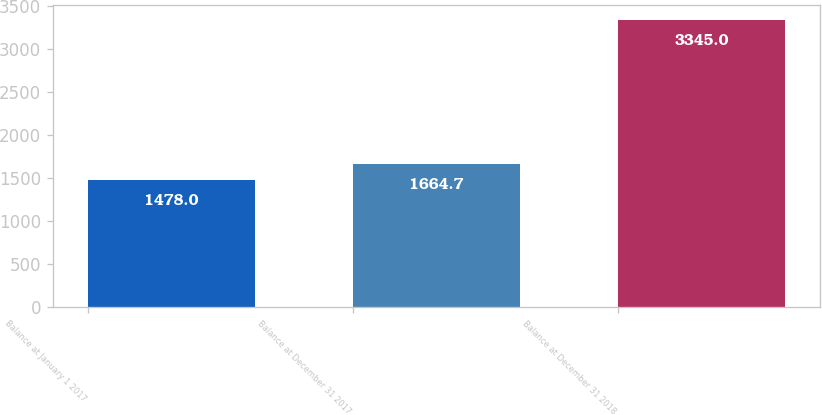Convert chart to OTSL. <chart><loc_0><loc_0><loc_500><loc_500><bar_chart><fcel>Balance at January 1 2017<fcel>Balance at December 31 2017<fcel>Balance at December 31 2018<nl><fcel>1478<fcel>1664.7<fcel>3345<nl></chart> 